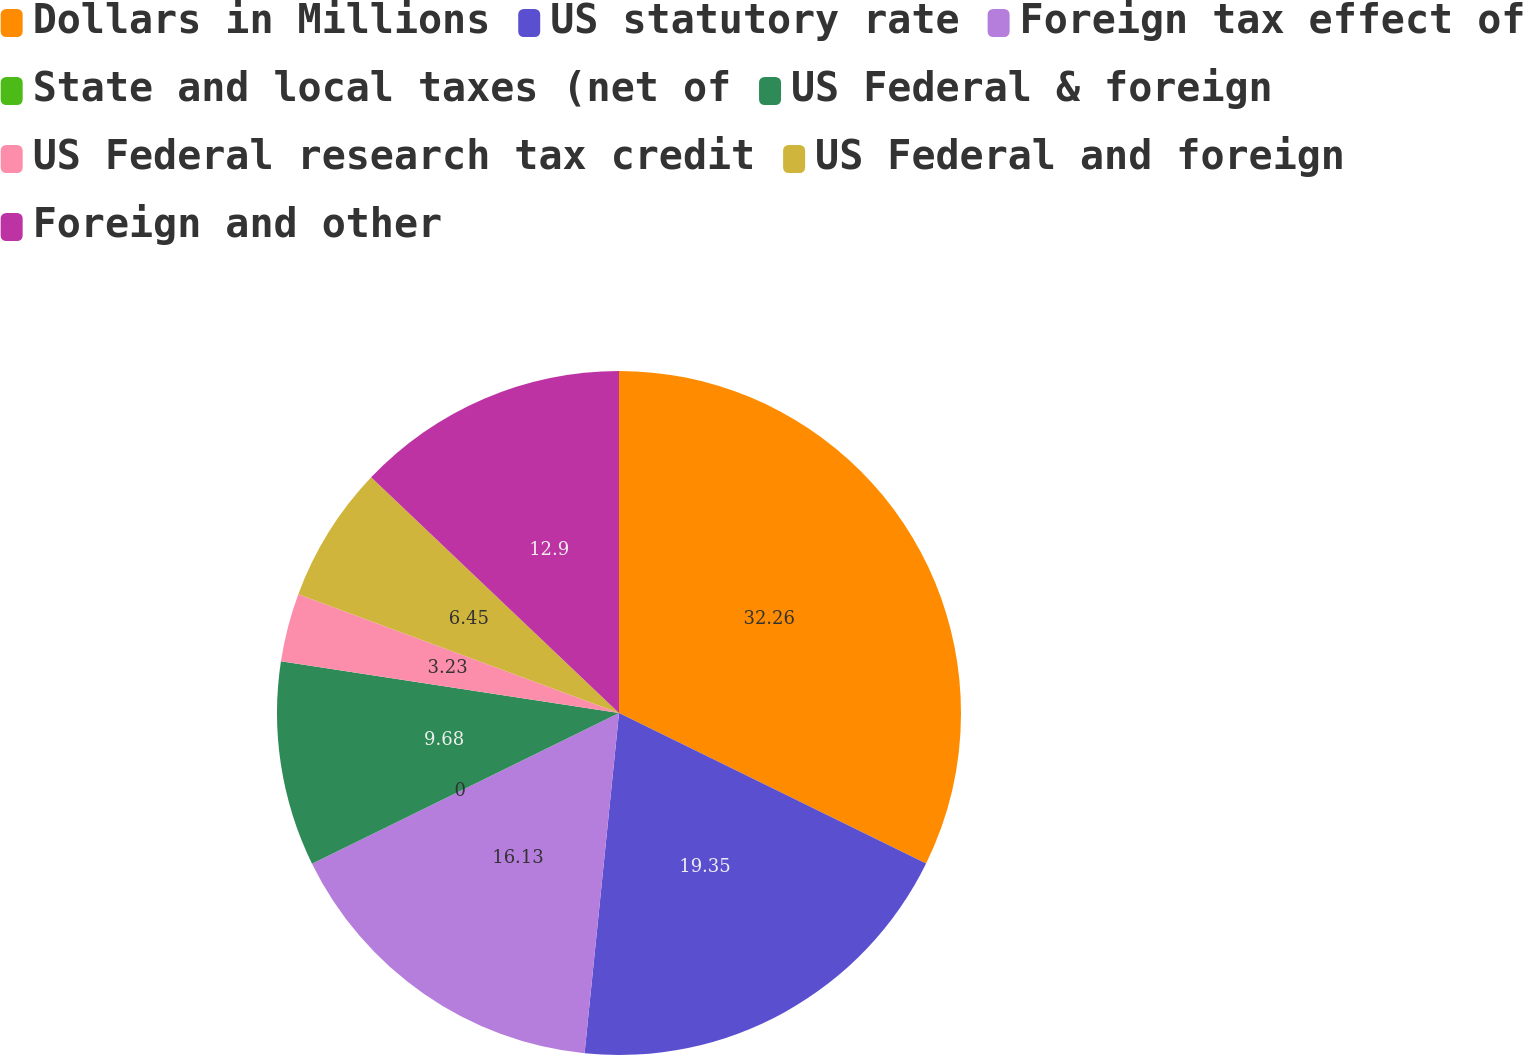Convert chart. <chart><loc_0><loc_0><loc_500><loc_500><pie_chart><fcel>Dollars in Millions<fcel>US statutory rate<fcel>Foreign tax effect of<fcel>State and local taxes (net of<fcel>US Federal & foreign<fcel>US Federal research tax credit<fcel>US Federal and foreign<fcel>Foreign and other<nl><fcel>32.25%<fcel>19.35%<fcel>16.13%<fcel>0.0%<fcel>9.68%<fcel>3.23%<fcel>6.45%<fcel>12.9%<nl></chart> 